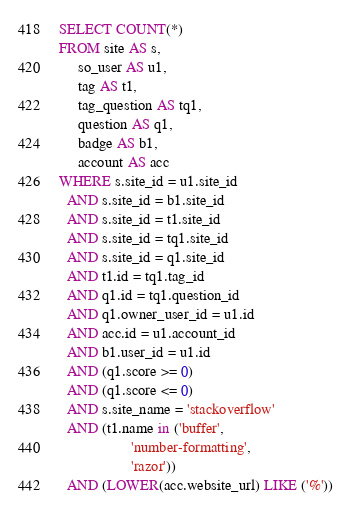<code> <loc_0><loc_0><loc_500><loc_500><_SQL_>SELECT COUNT(*)
FROM site AS s,
     so_user AS u1,
     tag AS t1,
     tag_question AS tq1,
     question AS q1,
     badge AS b1,
     account AS acc
WHERE s.site_id = u1.site_id
  AND s.site_id = b1.site_id
  AND s.site_id = t1.site_id
  AND s.site_id = tq1.site_id
  AND s.site_id = q1.site_id
  AND t1.id = tq1.tag_id
  AND q1.id = tq1.question_id
  AND q1.owner_user_id = u1.id
  AND acc.id = u1.account_id
  AND b1.user_id = u1.id
  AND (q1.score >= 0)
  AND (q1.score <= 0)
  AND s.site_name = 'stackoverflow'
  AND (t1.name in ('buffer',
                   'number-formatting',
                   'razor'))
  AND (LOWER(acc.website_url) LIKE ('%'))</code> 